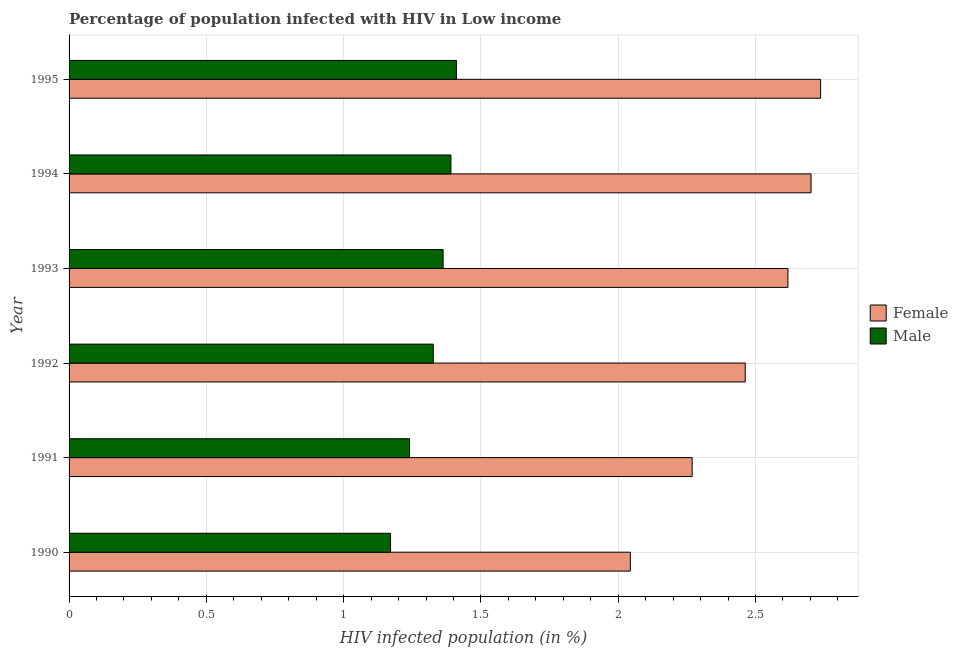How many different coloured bars are there?
Your answer should be very brief. 2. How many groups of bars are there?
Make the answer very short. 6. Are the number of bars per tick equal to the number of legend labels?
Give a very brief answer. Yes. How many bars are there on the 2nd tick from the bottom?
Your answer should be compact. 2. What is the percentage of males who are infected with hiv in 1990?
Keep it short and to the point. 1.17. Across all years, what is the maximum percentage of females who are infected with hiv?
Offer a terse response. 2.74. Across all years, what is the minimum percentage of females who are infected with hiv?
Your answer should be compact. 2.04. In which year was the percentage of females who are infected with hiv maximum?
Provide a succinct answer. 1995. What is the total percentage of males who are infected with hiv in the graph?
Your response must be concise. 7.9. What is the difference between the percentage of females who are infected with hiv in 1990 and that in 1992?
Give a very brief answer. -0.42. What is the difference between the percentage of females who are infected with hiv in 1992 and the percentage of males who are infected with hiv in 1991?
Offer a terse response. 1.22. What is the average percentage of females who are infected with hiv per year?
Offer a terse response. 2.47. In the year 1992, what is the difference between the percentage of males who are infected with hiv and percentage of females who are infected with hiv?
Ensure brevity in your answer.  -1.14. What is the ratio of the percentage of males who are infected with hiv in 1990 to that in 1993?
Your answer should be compact. 0.86. What is the difference between the highest and the second highest percentage of males who are infected with hiv?
Make the answer very short. 0.02. What is the difference between the highest and the lowest percentage of males who are infected with hiv?
Your answer should be compact. 0.24. What does the 1st bar from the bottom in 1993 represents?
Your answer should be very brief. Female. How many bars are there?
Your response must be concise. 12. Are all the bars in the graph horizontal?
Provide a short and direct response. Yes. How many years are there in the graph?
Ensure brevity in your answer.  6. What is the difference between two consecutive major ticks on the X-axis?
Give a very brief answer. 0.5. Does the graph contain any zero values?
Your answer should be very brief. No. Where does the legend appear in the graph?
Provide a short and direct response. Center right. What is the title of the graph?
Offer a very short reply. Percentage of population infected with HIV in Low income. Does "Lowest 10% of population" appear as one of the legend labels in the graph?
Provide a short and direct response. No. What is the label or title of the X-axis?
Give a very brief answer. HIV infected population (in %). What is the HIV infected population (in %) in Female in 1990?
Provide a short and direct response. 2.04. What is the HIV infected population (in %) of Male in 1990?
Ensure brevity in your answer.  1.17. What is the HIV infected population (in %) in Female in 1991?
Your answer should be compact. 2.27. What is the HIV infected population (in %) in Male in 1991?
Your answer should be compact. 1.24. What is the HIV infected population (in %) in Female in 1992?
Your answer should be compact. 2.46. What is the HIV infected population (in %) in Male in 1992?
Your answer should be very brief. 1.33. What is the HIV infected population (in %) in Female in 1993?
Offer a very short reply. 2.62. What is the HIV infected population (in %) of Male in 1993?
Give a very brief answer. 1.36. What is the HIV infected population (in %) in Female in 1994?
Offer a terse response. 2.7. What is the HIV infected population (in %) of Male in 1994?
Your answer should be compact. 1.39. What is the HIV infected population (in %) in Female in 1995?
Offer a terse response. 2.74. What is the HIV infected population (in %) of Male in 1995?
Make the answer very short. 1.41. Across all years, what is the maximum HIV infected population (in %) of Female?
Provide a short and direct response. 2.74. Across all years, what is the maximum HIV infected population (in %) in Male?
Give a very brief answer. 1.41. Across all years, what is the minimum HIV infected population (in %) of Female?
Offer a very short reply. 2.04. Across all years, what is the minimum HIV infected population (in %) of Male?
Ensure brevity in your answer.  1.17. What is the total HIV infected population (in %) in Female in the graph?
Offer a very short reply. 14.83. What is the total HIV infected population (in %) in Male in the graph?
Your response must be concise. 7.9. What is the difference between the HIV infected population (in %) in Female in 1990 and that in 1991?
Make the answer very short. -0.23. What is the difference between the HIV infected population (in %) in Male in 1990 and that in 1991?
Make the answer very short. -0.07. What is the difference between the HIV infected population (in %) in Female in 1990 and that in 1992?
Keep it short and to the point. -0.42. What is the difference between the HIV infected population (in %) in Male in 1990 and that in 1992?
Provide a short and direct response. -0.16. What is the difference between the HIV infected population (in %) of Female in 1990 and that in 1993?
Give a very brief answer. -0.57. What is the difference between the HIV infected population (in %) in Male in 1990 and that in 1993?
Provide a short and direct response. -0.19. What is the difference between the HIV infected population (in %) in Female in 1990 and that in 1994?
Keep it short and to the point. -0.66. What is the difference between the HIV infected population (in %) of Male in 1990 and that in 1994?
Offer a terse response. -0.22. What is the difference between the HIV infected population (in %) of Female in 1990 and that in 1995?
Provide a short and direct response. -0.69. What is the difference between the HIV infected population (in %) of Male in 1990 and that in 1995?
Provide a short and direct response. -0.24. What is the difference between the HIV infected population (in %) in Female in 1991 and that in 1992?
Your response must be concise. -0.19. What is the difference between the HIV infected population (in %) of Male in 1991 and that in 1992?
Keep it short and to the point. -0.09. What is the difference between the HIV infected population (in %) of Female in 1991 and that in 1993?
Ensure brevity in your answer.  -0.35. What is the difference between the HIV infected population (in %) of Male in 1991 and that in 1993?
Offer a terse response. -0.12. What is the difference between the HIV infected population (in %) of Female in 1991 and that in 1994?
Give a very brief answer. -0.43. What is the difference between the HIV infected population (in %) of Male in 1991 and that in 1994?
Your response must be concise. -0.15. What is the difference between the HIV infected population (in %) of Female in 1991 and that in 1995?
Your response must be concise. -0.47. What is the difference between the HIV infected population (in %) in Male in 1991 and that in 1995?
Keep it short and to the point. -0.17. What is the difference between the HIV infected population (in %) of Female in 1992 and that in 1993?
Your answer should be compact. -0.16. What is the difference between the HIV infected population (in %) of Male in 1992 and that in 1993?
Give a very brief answer. -0.04. What is the difference between the HIV infected population (in %) in Female in 1992 and that in 1994?
Offer a terse response. -0.24. What is the difference between the HIV infected population (in %) of Male in 1992 and that in 1994?
Your answer should be compact. -0.06. What is the difference between the HIV infected population (in %) in Female in 1992 and that in 1995?
Ensure brevity in your answer.  -0.27. What is the difference between the HIV infected population (in %) of Male in 1992 and that in 1995?
Give a very brief answer. -0.08. What is the difference between the HIV infected population (in %) of Female in 1993 and that in 1994?
Provide a succinct answer. -0.08. What is the difference between the HIV infected population (in %) in Male in 1993 and that in 1994?
Give a very brief answer. -0.03. What is the difference between the HIV infected population (in %) in Female in 1993 and that in 1995?
Give a very brief answer. -0.12. What is the difference between the HIV infected population (in %) in Male in 1993 and that in 1995?
Provide a short and direct response. -0.05. What is the difference between the HIV infected population (in %) of Female in 1994 and that in 1995?
Your answer should be very brief. -0.03. What is the difference between the HIV infected population (in %) in Male in 1994 and that in 1995?
Your answer should be very brief. -0.02. What is the difference between the HIV infected population (in %) of Female in 1990 and the HIV infected population (in %) of Male in 1991?
Your answer should be compact. 0.8. What is the difference between the HIV infected population (in %) in Female in 1990 and the HIV infected population (in %) in Male in 1992?
Ensure brevity in your answer.  0.72. What is the difference between the HIV infected population (in %) of Female in 1990 and the HIV infected population (in %) of Male in 1993?
Your answer should be compact. 0.68. What is the difference between the HIV infected population (in %) of Female in 1990 and the HIV infected population (in %) of Male in 1994?
Your answer should be very brief. 0.65. What is the difference between the HIV infected population (in %) of Female in 1990 and the HIV infected population (in %) of Male in 1995?
Keep it short and to the point. 0.63. What is the difference between the HIV infected population (in %) in Female in 1991 and the HIV infected population (in %) in Male in 1992?
Provide a succinct answer. 0.94. What is the difference between the HIV infected population (in %) in Female in 1991 and the HIV infected population (in %) in Male in 1993?
Make the answer very short. 0.91. What is the difference between the HIV infected population (in %) of Female in 1991 and the HIV infected population (in %) of Male in 1994?
Give a very brief answer. 0.88. What is the difference between the HIV infected population (in %) of Female in 1991 and the HIV infected population (in %) of Male in 1995?
Provide a short and direct response. 0.86. What is the difference between the HIV infected population (in %) of Female in 1992 and the HIV infected population (in %) of Male in 1993?
Give a very brief answer. 1.1. What is the difference between the HIV infected population (in %) of Female in 1992 and the HIV infected population (in %) of Male in 1994?
Your answer should be compact. 1.07. What is the difference between the HIV infected population (in %) of Female in 1992 and the HIV infected population (in %) of Male in 1995?
Make the answer very short. 1.05. What is the difference between the HIV infected population (in %) in Female in 1993 and the HIV infected population (in %) in Male in 1994?
Your answer should be compact. 1.23. What is the difference between the HIV infected population (in %) of Female in 1993 and the HIV infected population (in %) of Male in 1995?
Your answer should be compact. 1.21. What is the difference between the HIV infected population (in %) of Female in 1994 and the HIV infected population (in %) of Male in 1995?
Ensure brevity in your answer.  1.29. What is the average HIV infected population (in %) of Female per year?
Make the answer very short. 2.47. What is the average HIV infected population (in %) in Male per year?
Provide a succinct answer. 1.32. In the year 1990, what is the difference between the HIV infected population (in %) of Female and HIV infected population (in %) of Male?
Ensure brevity in your answer.  0.87. In the year 1991, what is the difference between the HIV infected population (in %) in Female and HIV infected population (in %) in Male?
Your response must be concise. 1.03. In the year 1992, what is the difference between the HIV infected population (in %) of Female and HIV infected population (in %) of Male?
Your answer should be compact. 1.14. In the year 1993, what is the difference between the HIV infected population (in %) in Female and HIV infected population (in %) in Male?
Ensure brevity in your answer.  1.26. In the year 1994, what is the difference between the HIV infected population (in %) in Female and HIV infected population (in %) in Male?
Offer a terse response. 1.31. In the year 1995, what is the difference between the HIV infected population (in %) in Female and HIV infected population (in %) in Male?
Make the answer very short. 1.33. What is the ratio of the HIV infected population (in %) in Female in 1990 to that in 1991?
Offer a terse response. 0.9. What is the ratio of the HIV infected population (in %) in Male in 1990 to that in 1991?
Offer a terse response. 0.94. What is the ratio of the HIV infected population (in %) of Female in 1990 to that in 1992?
Make the answer very short. 0.83. What is the ratio of the HIV infected population (in %) of Male in 1990 to that in 1992?
Your answer should be compact. 0.88. What is the ratio of the HIV infected population (in %) of Female in 1990 to that in 1993?
Offer a very short reply. 0.78. What is the ratio of the HIV infected population (in %) of Male in 1990 to that in 1993?
Your answer should be compact. 0.86. What is the ratio of the HIV infected population (in %) in Female in 1990 to that in 1994?
Provide a succinct answer. 0.76. What is the ratio of the HIV infected population (in %) of Male in 1990 to that in 1994?
Your answer should be very brief. 0.84. What is the ratio of the HIV infected population (in %) in Female in 1990 to that in 1995?
Your response must be concise. 0.75. What is the ratio of the HIV infected population (in %) of Male in 1990 to that in 1995?
Your answer should be compact. 0.83. What is the ratio of the HIV infected population (in %) in Female in 1991 to that in 1992?
Give a very brief answer. 0.92. What is the ratio of the HIV infected population (in %) in Male in 1991 to that in 1992?
Your response must be concise. 0.93. What is the ratio of the HIV infected population (in %) of Female in 1991 to that in 1993?
Give a very brief answer. 0.87. What is the ratio of the HIV infected population (in %) in Male in 1991 to that in 1993?
Your answer should be compact. 0.91. What is the ratio of the HIV infected population (in %) in Female in 1991 to that in 1994?
Offer a very short reply. 0.84. What is the ratio of the HIV infected population (in %) in Male in 1991 to that in 1994?
Give a very brief answer. 0.89. What is the ratio of the HIV infected population (in %) of Female in 1991 to that in 1995?
Your answer should be compact. 0.83. What is the ratio of the HIV infected population (in %) in Male in 1991 to that in 1995?
Make the answer very short. 0.88. What is the ratio of the HIV infected population (in %) in Female in 1992 to that in 1993?
Offer a terse response. 0.94. What is the ratio of the HIV infected population (in %) in Male in 1992 to that in 1993?
Your answer should be very brief. 0.97. What is the ratio of the HIV infected population (in %) of Female in 1992 to that in 1994?
Provide a succinct answer. 0.91. What is the ratio of the HIV infected population (in %) in Male in 1992 to that in 1994?
Give a very brief answer. 0.95. What is the ratio of the HIV infected population (in %) of Female in 1992 to that in 1995?
Make the answer very short. 0.9. What is the ratio of the HIV infected population (in %) of Male in 1992 to that in 1995?
Your answer should be very brief. 0.94. What is the ratio of the HIV infected population (in %) in Female in 1993 to that in 1994?
Your response must be concise. 0.97. What is the ratio of the HIV infected population (in %) in Male in 1993 to that in 1994?
Offer a terse response. 0.98. What is the ratio of the HIV infected population (in %) of Female in 1993 to that in 1995?
Keep it short and to the point. 0.96. What is the ratio of the HIV infected population (in %) in Male in 1993 to that in 1995?
Your answer should be compact. 0.97. What is the ratio of the HIV infected population (in %) in Female in 1994 to that in 1995?
Provide a short and direct response. 0.99. What is the ratio of the HIV infected population (in %) in Male in 1994 to that in 1995?
Provide a short and direct response. 0.99. What is the difference between the highest and the second highest HIV infected population (in %) of Female?
Give a very brief answer. 0.03. What is the difference between the highest and the second highest HIV infected population (in %) in Male?
Give a very brief answer. 0.02. What is the difference between the highest and the lowest HIV infected population (in %) of Female?
Give a very brief answer. 0.69. What is the difference between the highest and the lowest HIV infected population (in %) in Male?
Provide a short and direct response. 0.24. 